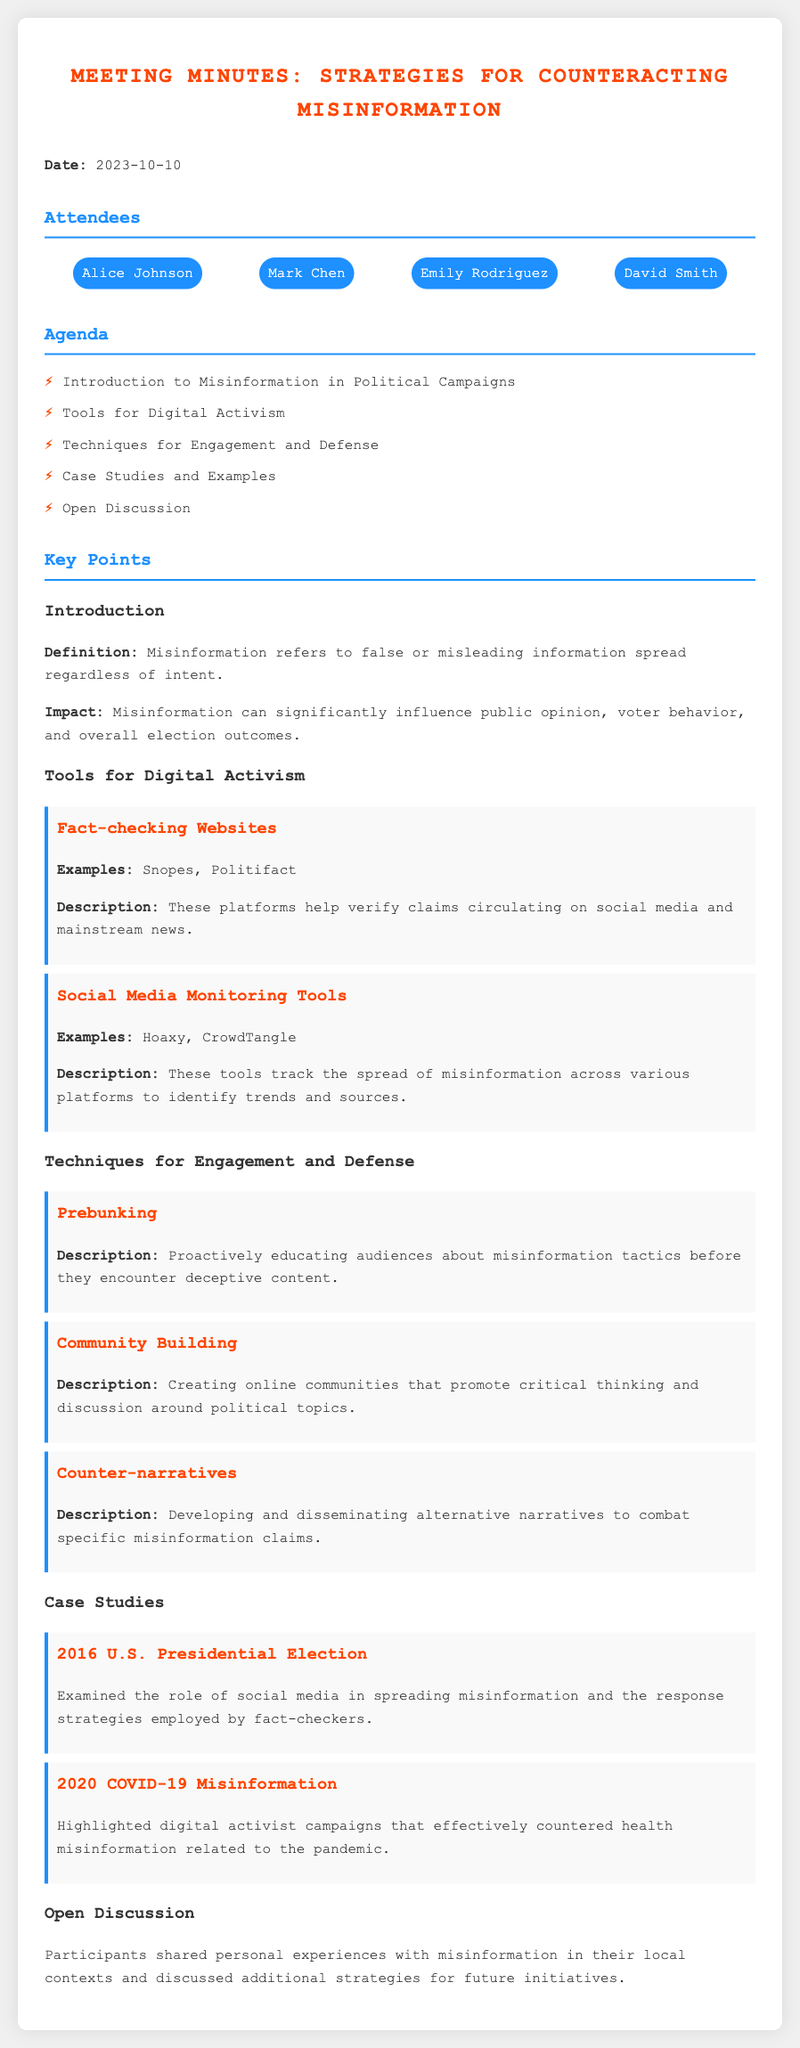What is the date of the meeting? The date of the meeting is provided at the beginning of the document.
Answer: 2023-10-10 Who is one of the attendees? The attendees list includes several names, and I need one as the answer.
Answer: Alice Johnson What is the first tool for digital activism mentioned? The document lists tools and includes a fact-checking website as the first item under tools.
Answer: Fact-checking Websites What does "Prebunking" involve? The description for the technique "Prebunking" is given in the corresponding section of the document.
Answer: Proactively educating audiences How many case studies are presented? The document lists the number of case studies included in the section on case studies.
Answer: 2 What was examined in the case study about the 2016 U.S. Presidential Election? The focus of the case study is mentioned in its description.
Answer: Role of social media What technique is associated with fostering discussions around political topics? The specific technique aimed at creating discourse is explicitly described in the document.
Answer: Community Building What is the impact of misinformation according to the introduction? The introduction section provides insights about misinformation that affect certain aspects.
Answer: Influence public opinion What is the last item discussed in the agenda? The agenda section lists the items, and I need to identify the last one listed.
Answer: Open Discussion 